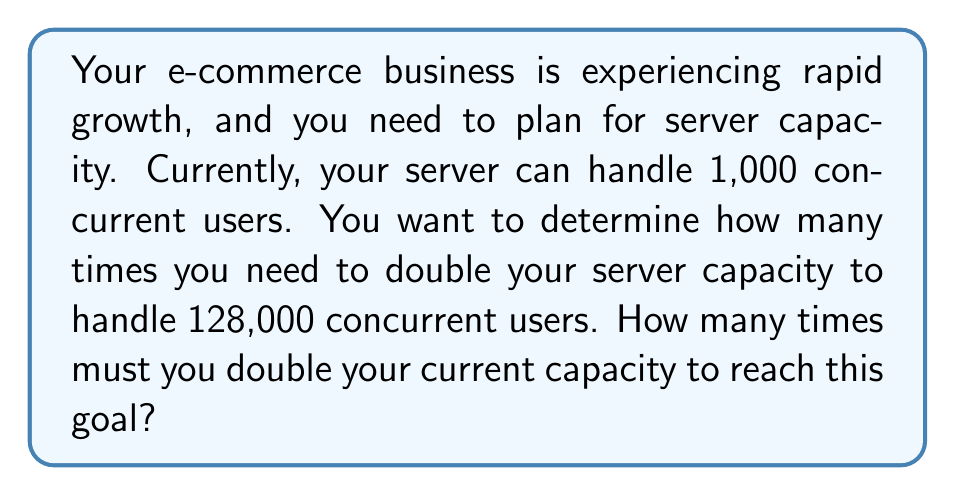Solve this math problem. Let's approach this step-by-step:

1) We start with 1,000 users and want to reach 128,000 users.

2) Let $x$ be the number of times we need to double the capacity.

3) We can express this mathematically as:

   $1000 \cdot 2^x = 128000$

4) To solve for $x$, we can use logarithms. Let's apply $\log_2$ to both sides:

   $\log_2(1000 \cdot 2^x) = \log_2(128000)$

5) Using the logarithm product rule:

   $\log_2(1000) + \log_2(2^x) = \log_2(128000)$

6) Simplify $\log_2(2^x)$:

   $\log_2(1000) + x = \log_2(128000)$

7) Now we can solve for $x$:

   $x = \log_2(128000) - \log_2(1000)$

8) Using the change of base formula:

   $x = \frac{\log(128000)}{\log(2)} - \frac{\log(1000)}{\log(2)}$

9) Simplify:

   $x = \frac{\log(128000) - \log(1000)}{\log(2)}$

10) Calculate:

    $x = \frac{\log(128) + \log(1000) - \log(1000)}{\log(2)} = \frac{\log(128)}{\log(2)} = 7$

Therefore, you need to double your server capacity 7 times to handle 128,000 concurrent users.
Answer: 7 times 